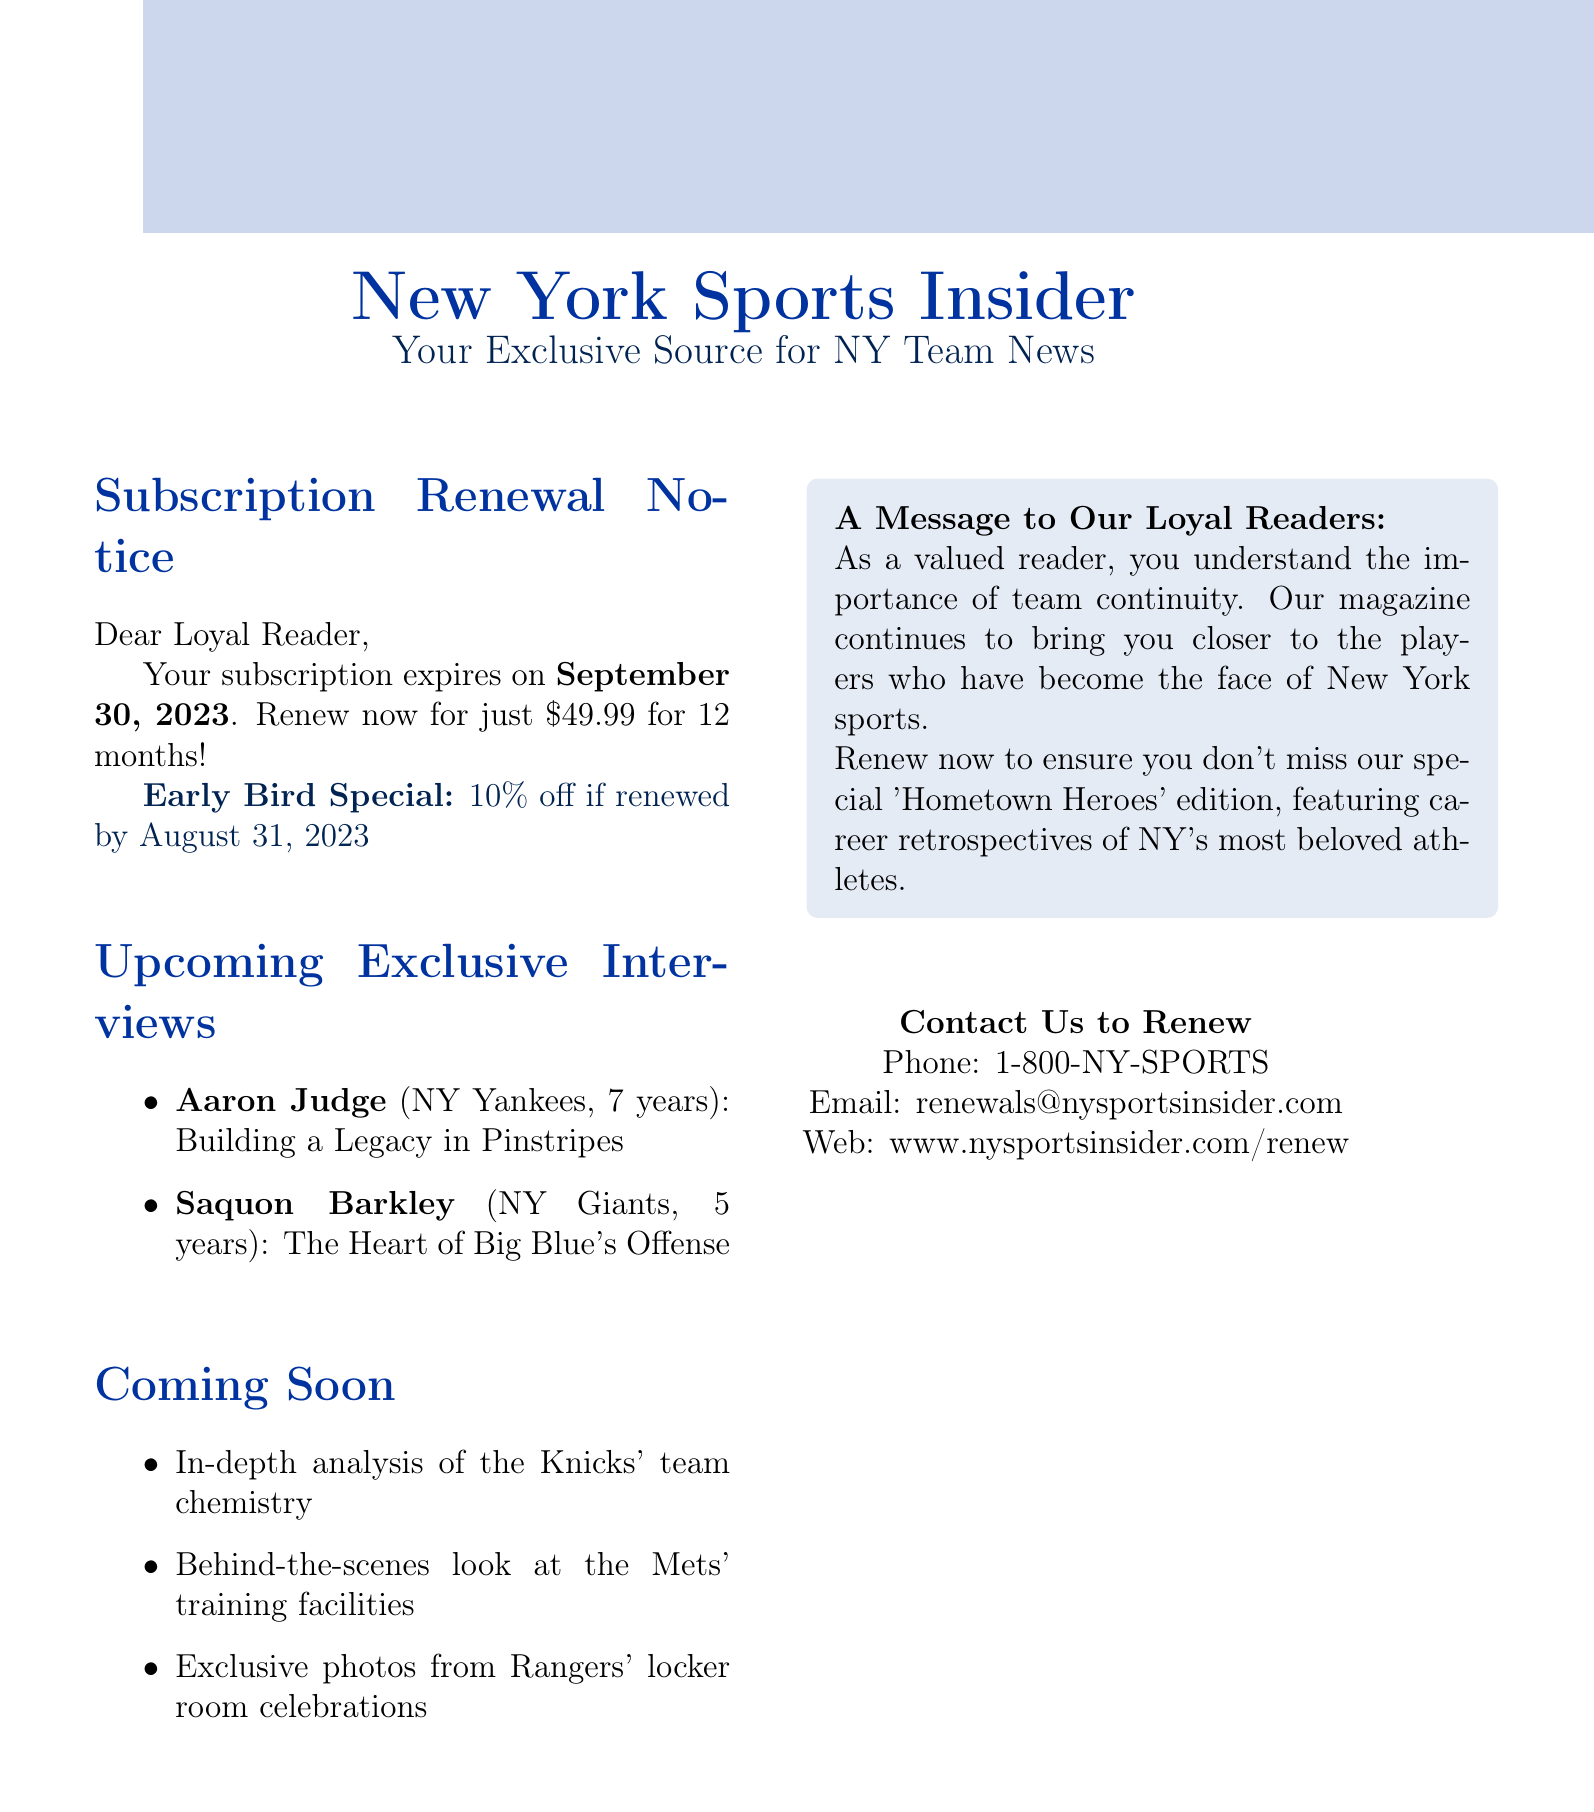What is the magazine's name? The magazine's name is explicitly mentioned at the top of the document.
Answer: New York Sports Insider When does the subscription expire? The expiration date of the subscription is clearly stated in the document.
Answer: September 30, 2023 How much is the renewal price for 12 months? The renewal price is specified as one of the subscription details in the document.
Answer: $49.99 for 12 months What is the early bird discount percentage? The early bird discount is presented in the subscription details section of the document.
Answer: 10% Who is featured in the upcoming exclusive interviews? The document lists two players along with their respective teams and interview topics.
Answer: Aaron Judge and Saquon Barkley What is the topic of Aaron Judge's interview? The document specifies the interview topic for the player directly.
Answer: Building a Legacy in Pinstripes Why is the magazine emphasizing team continuity? This reasoning is rooted in the loyalty message that reflects a connection to long-standing players.
Answer: Importance of team continuity What special edition is mentioned for renewal? The document includes a specific edition title to encourage subscription renewal.
Answer: Hometown Heroes 